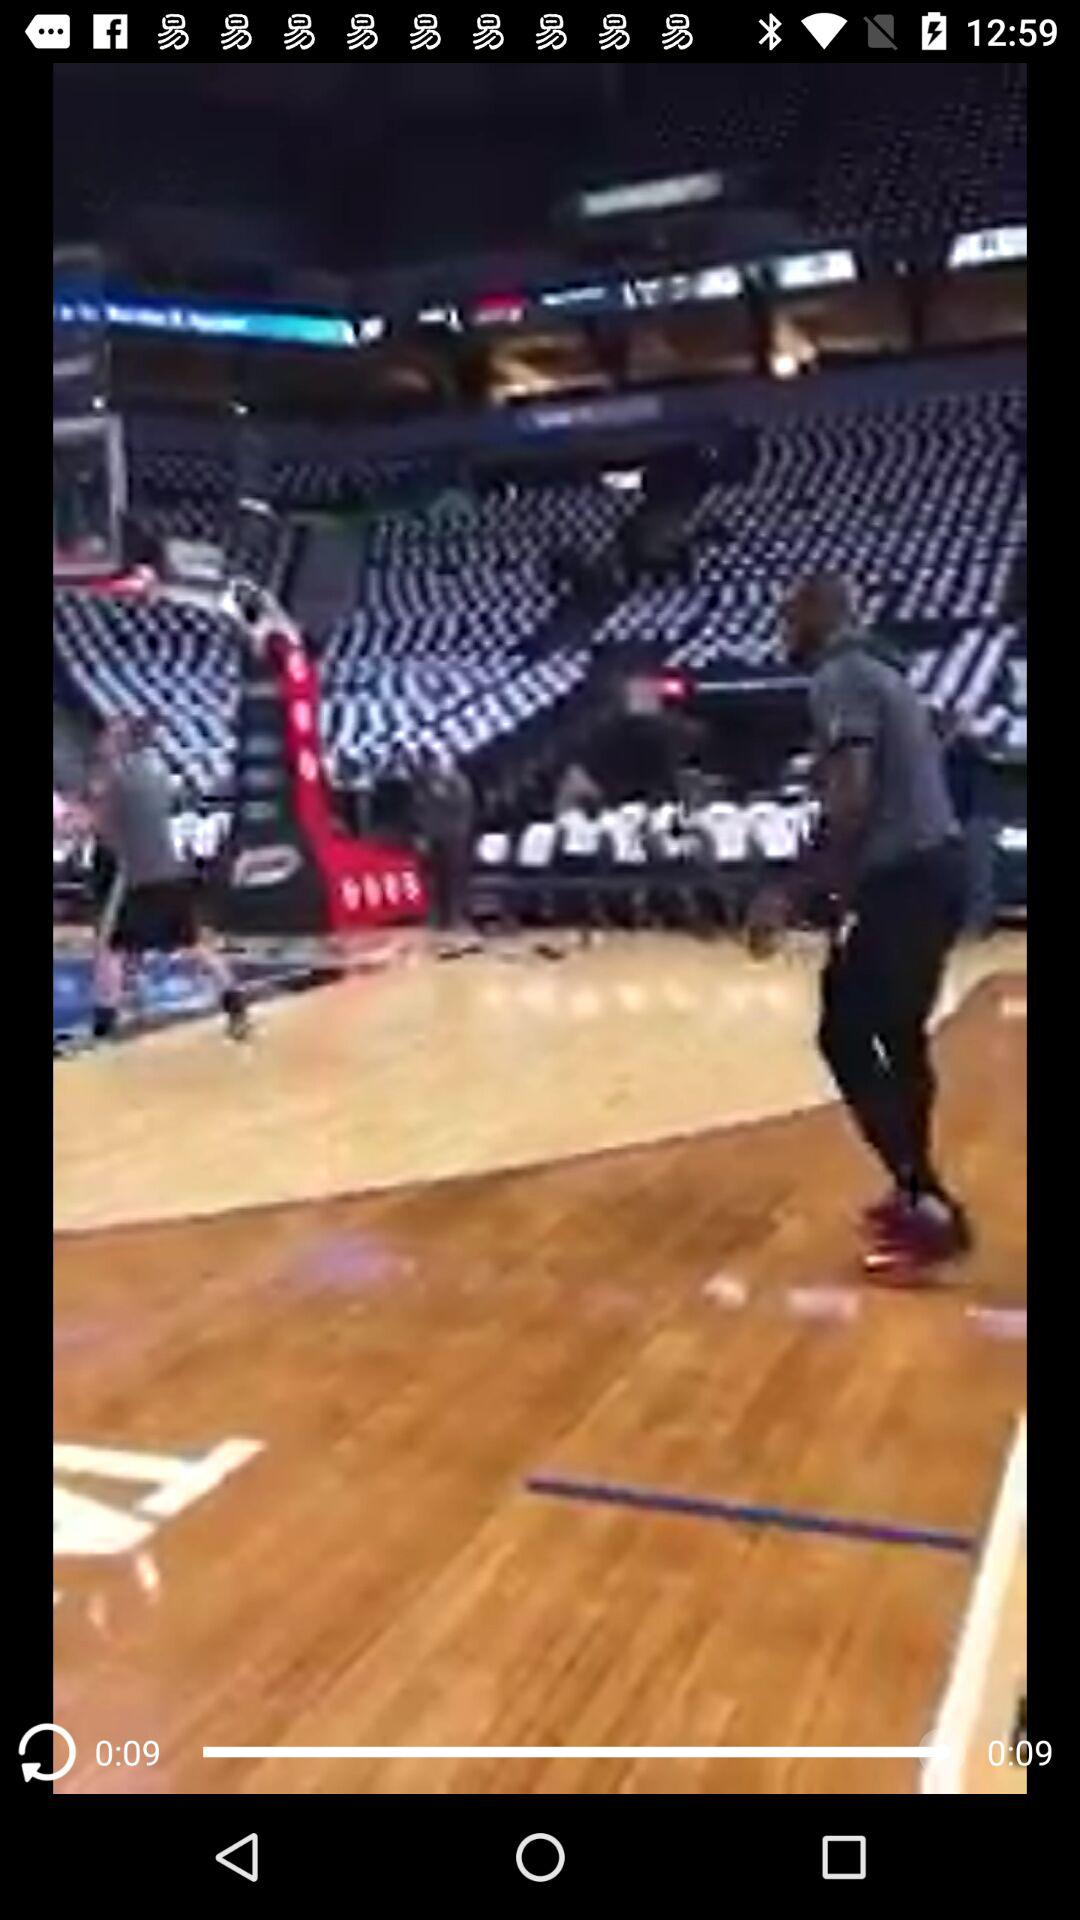What is the duration of the video? The duration is 9 seconds. 